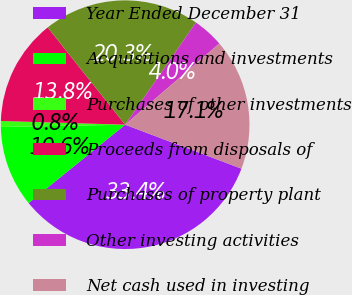<chart> <loc_0><loc_0><loc_500><loc_500><pie_chart><fcel>Year Ended December 31<fcel>Acquisitions and investments<fcel>Purchases of other investments<fcel>Proceeds from disposals of<fcel>Purchases of property plant<fcel>Other investing activities<fcel>Net cash used in investing<nl><fcel>33.4%<fcel>10.56%<fcel>0.77%<fcel>13.82%<fcel>20.35%<fcel>4.03%<fcel>17.08%<nl></chart> 